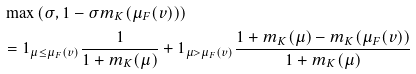Convert formula to latex. <formula><loc_0><loc_0><loc_500><loc_500>& \max \left ( \sigma , 1 - \sigma m _ { K } ( \mu _ { F } ( v ) ) \right ) \\ & = 1 _ { \mu \leq \mu _ { F } ( v ) } \frac { 1 } { 1 + m _ { K } ( \mu ) } + 1 _ { \mu > \mu _ { F } ( v ) } \frac { 1 + m _ { K } ( \mu ) - m _ { K } ( \mu _ { F } ( v ) ) } { 1 + m _ { K } ( \mu ) }</formula> 